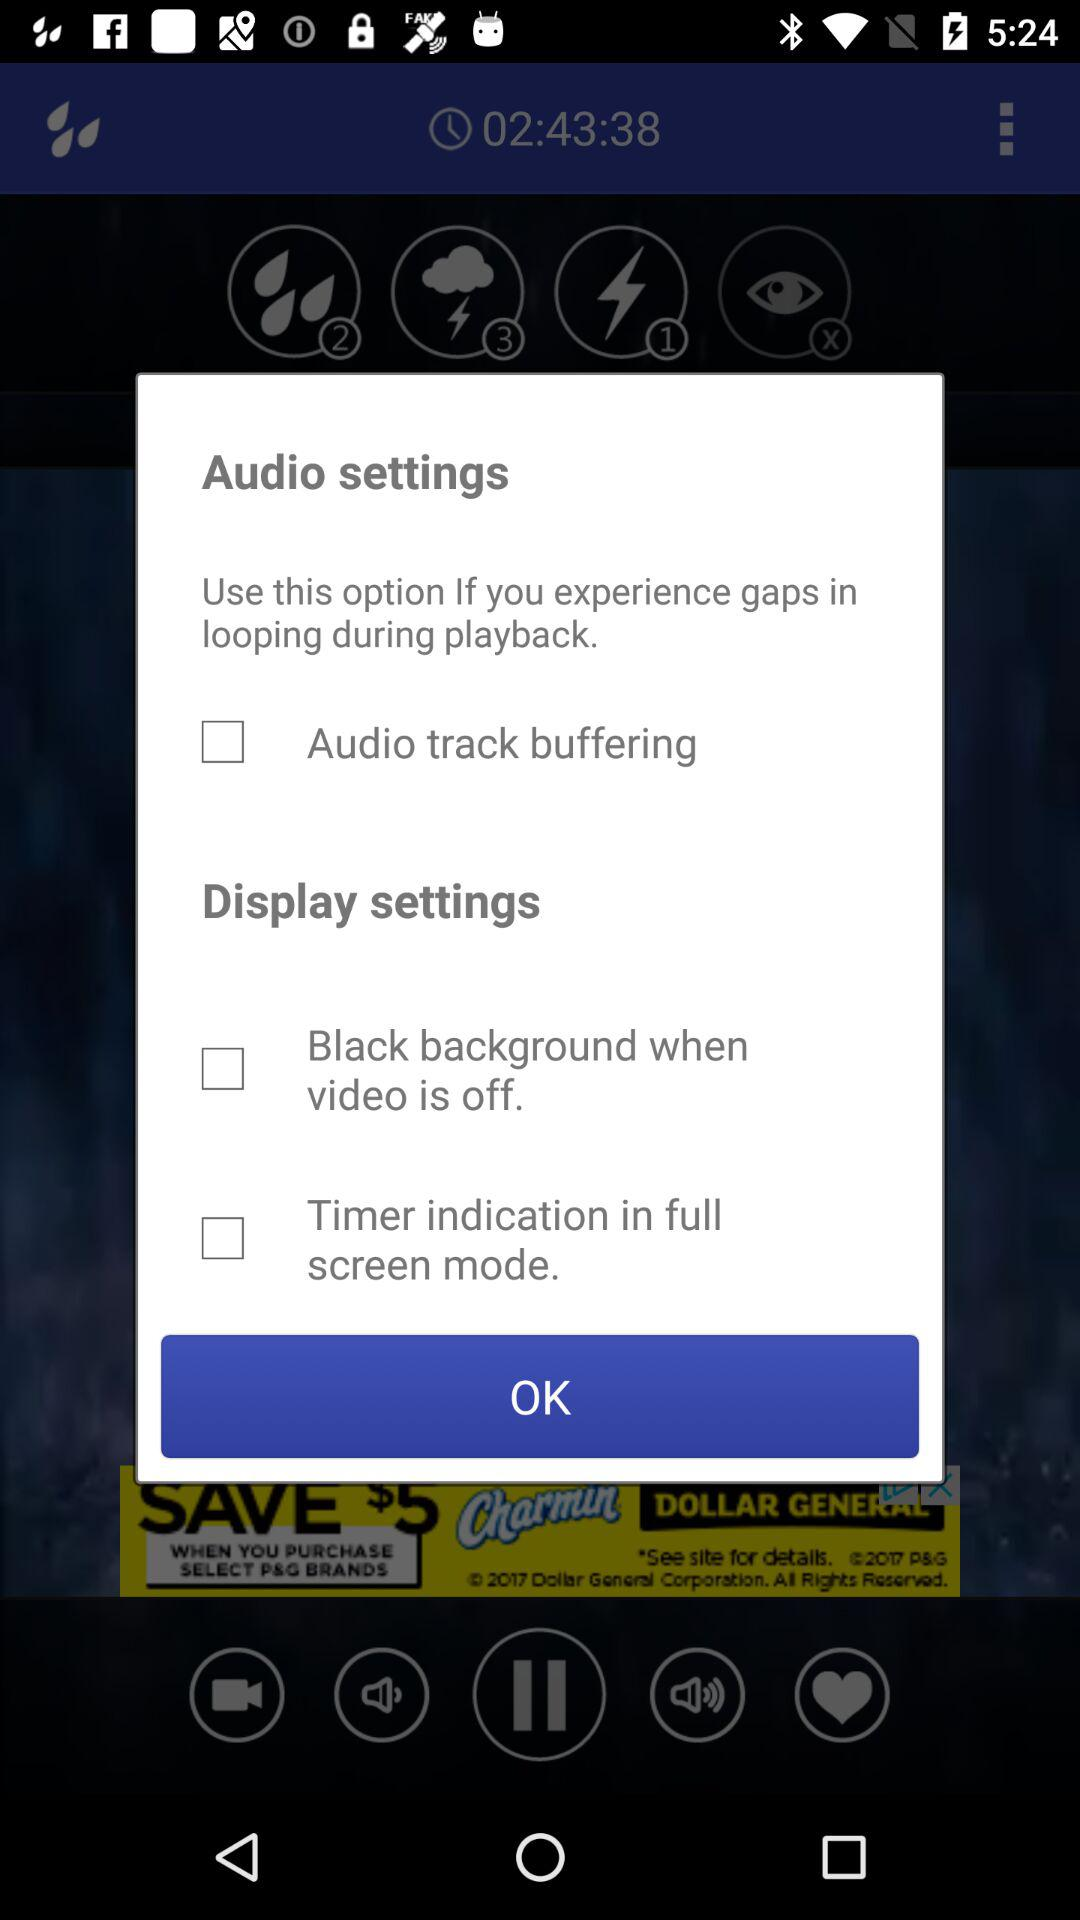What is the status of "Audio track buffering"? The status of "Audio track buffering" is "off". 